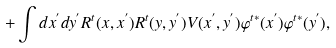<formula> <loc_0><loc_0><loc_500><loc_500>+ \int d x ^ { ^ { \prime } } d y ^ { ^ { \prime } } R ^ { t } ( x , x ^ { ^ { \prime } } ) R ^ { t } ( y , y ^ { ^ { \prime } } ) V ( x ^ { ^ { \prime } } , y ^ { ^ { \prime } } ) \varphi ^ { t * } ( x ^ { ^ { \prime } } ) \varphi ^ { t * } ( y ^ { ^ { \prime } } ) ,</formula> 